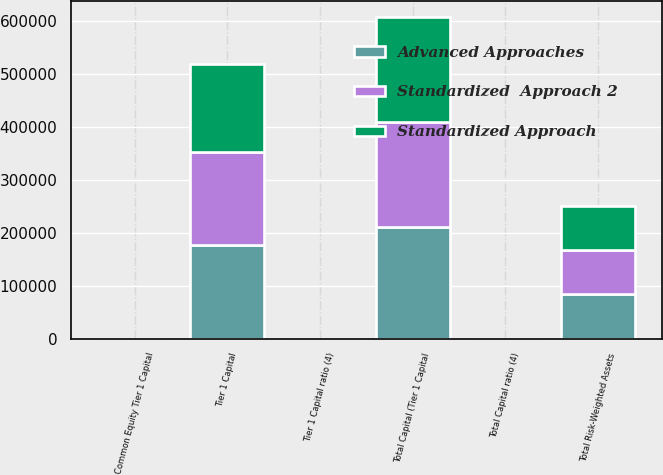Convert chart. <chart><loc_0><loc_0><loc_500><loc_500><stacked_bar_chart><ecel><fcel>Common Equity Tier 1 Capital<fcel>Tier 1 Capital<fcel>Total Capital (Tier 1 Capital<fcel>Total Risk-Weighted Assets<fcel>Tier 1 Capital ratio (4)<fcel>Total Capital ratio (4)<nl><fcel>Standardized  Approach 2<fcel>14.6<fcel>176420<fcel>198746<fcel>83340.8<fcel>14.81<fcel>16.69<nl><fcel>Advanced Approaches<fcel>15.27<fcel>176420<fcel>211115<fcel>83340.8<fcel>15.49<fcel>18.54<nl><fcel>Standardized Approach<fcel>13.76<fcel>166663<fcel>197707<fcel>83340.8<fcel>13.76<fcel>16.32<nl></chart> 